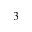Convert formula to latex. <formula><loc_0><loc_0><loc_500><loc_500>3</formula> 